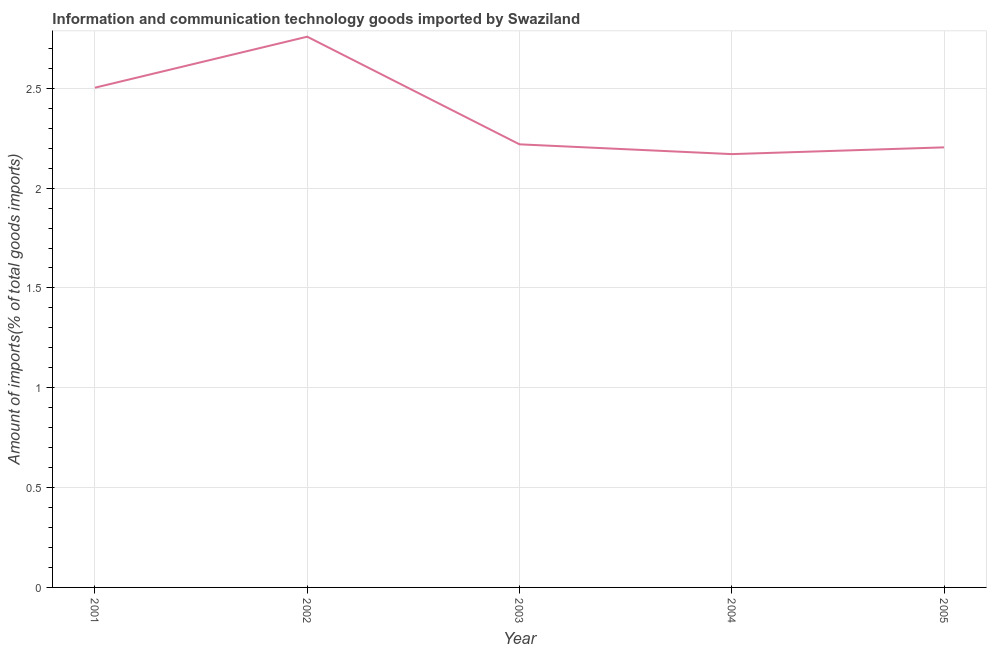What is the amount of ict goods imports in 2004?
Provide a short and direct response. 2.17. Across all years, what is the maximum amount of ict goods imports?
Offer a terse response. 2.76. Across all years, what is the minimum amount of ict goods imports?
Keep it short and to the point. 2.17. In which year was the amount of ict goods imports maximum?
Make the answer very short. 2002. In which year was the amount of ict goods imports minimum?
Your answer should be very brief. 2004. What is the sum of the amount of ict goods imports?
Keep it short and to the point. 11.85. What is the difference between the amount of ict goods imports in 2002 and 2005?
Provide a short and direct response. 0.55. What is the average amount of ict goods imports per year?
Offer a terse response. 2.37. What is the median amount of ict goods imports?
Provide a succinct answer. 2.22. In how many years, is the amount of ict goods imports greater than 2.4 %?
Offer a very short reply. 2. What is the ratio of the amount of ict goods imports in 2003 to that in 2004?
Keep it short and to the point. 1.02. What is the difference between the highest and the second highest amount of ict goods imports?
Give a very brief answer. 0.26. What is the difference between the highest and the lowest amount of ict goods imports?
Make the answer very short. 0.59. In how many years, is the amount of ict goods imports greater than the average amount of ict goods imports taken over all years?
Your response must be concise. 2. How many years are there in the graph?
Provide a short and direct response. 5. Does the graph contain grids?
Provide a succinct answer. Yes. What is the title of the graph?
Give a very brief answer. Information and communication technology goods imported by Swaziland. What is the label or title of the X-axis?
Keep it short and to the point. Year. What is the label or title of the Y-axis?
Offer a terse response. Amount of imports(% of total goods imports). What is the Amount of imports(% of total goods imports) of 2001?
Provide a succinct answer. 2.5. What is the Amount of imports(% of total goods imports) of 2002?
Provide a short and direct response. 2.76. What is the Amount of imports(% of total goods imports) of 2003?
Your answer should be very brief. 2.22. What is the Amount of imports(% of total goods imports) of 2004?
Offer a terse response. 2.17. What is the Amount of imports(% of total goods imports) in 2005?
Provide a succinct answer. 2.2. What is the difference between the Amount of imports(% of total goods imports) in 2001 and 2002?
Your answer should be compact. -0.26. What is the difference between the Amount of imports(% of total goods imports) in 2001 and 2003?
Give a very brief answer. 0.28. What is the difference between the Amount of imports(% of total goods imports) in 2001 and 2004?
Your answer should be compact. 0.33. What is the difference between the Amount of imports(% of total goods imports) in 2001 and 2005?
Your answer should be compact. 0.3. What is the difference between the Amount of imports(% of total goods imports) in 2002 and 2003?
Your answer should be very brief. 0.54. What is the difference between the Amount of imports(% of total goods imports) in 2002 and 2004?
Keep it short and to the point. 0.59. What is the difference between the Amount of imports(% of total goods imports) in 2002 and 2005?
Keep it short and to the point. 0.55. What is the difference between the Amount of imports(% of total goods imports) in 2003 and 2004?
Ensure brevity in your answer.  0.05. What is the difference between the Amount of imports(% of total goods imports) in 2003 and 2005?
Provide a succinct answer. 0.02. What is the difference between the Amount of imports(% of total goods imports) in 2004 and 2005?
Make the answer very short. -0.03. What is the ratio of the Amount of imports(% of total goods imports) in 2001 to that in 2002?
Your answer should be compact. 0.91. What is the ratio of the Amount of imports(% of total goods imports) in 2001 to that in 2003?
Give a very brief answer. 1.13. What is the ratio of the Amount of imports(% of total goods imports) in 2001 to that in 2004?
Keep it short and to the point. 1.15. What is the ratio of the Amount of imports(% of total goods imports) in 2001 to that in 2005?
Give a very brief answer. 1.14. What is the ratio of the Amount of imports(% of total goods imports) in 2002 to that in 2003?
Offer a very short reply. 1.24. What is the ratio of the Amount of imports(% of total goods imports) in 2002 to that in 2004?
Your answer should be very brief. 1.27. What is the ratio of the Amount of imports(% of total goods imports) in 2002 to that in 2005?
Provide a succinct answer. 1.25. What is the ratio of the Amount of imports(% of total goods imports) in 2003 to that in 2005?
Your answer should be very brief. 1.01. 